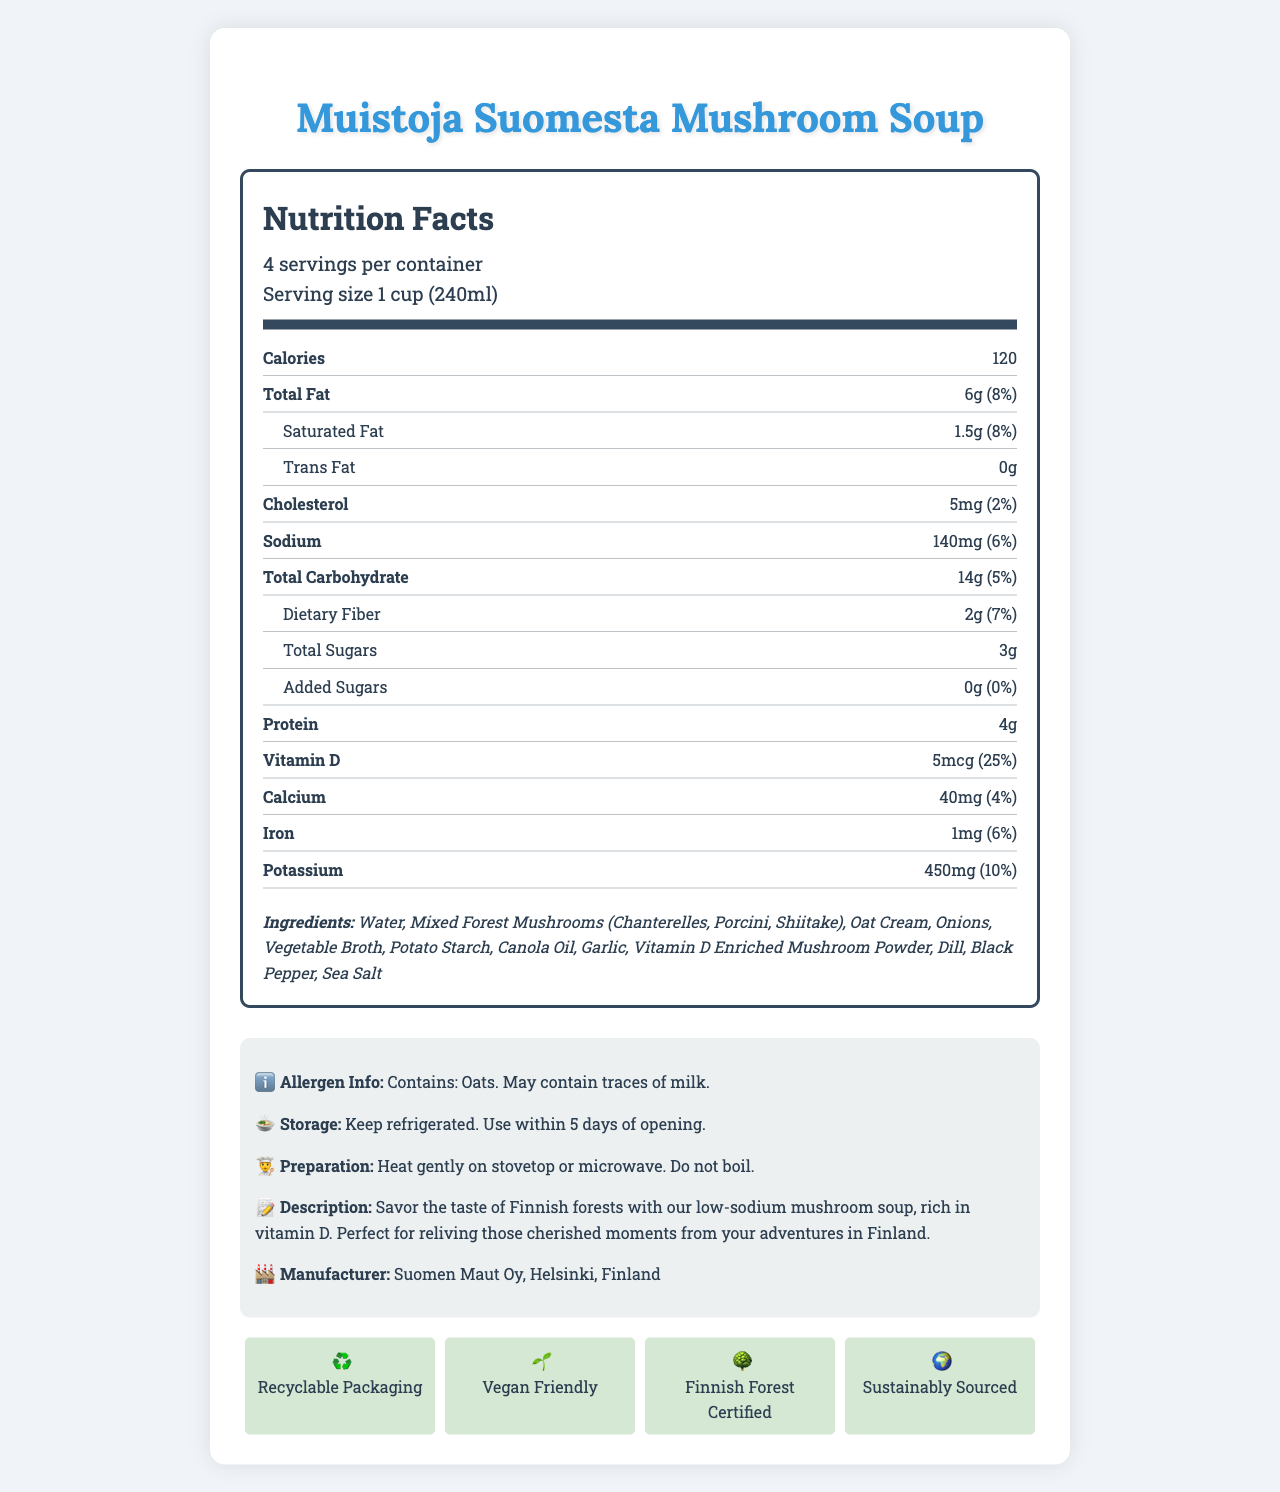what is the serving size? The serving size is stated in the serving information section as "1 cup (240ml)".
Answer: 1 cup (240ml) how many calories are in one serving? The document lists 120 calories per serving in the nutrient section.
Answer: 120 which component has the highest daily value percentage? In the nutrient section, Vitamin D has the highest daily value percentage, which is 25%.
Answer: Vitamin D (25%) what is the amount of sodium per serving? The sodium content per serving is listed as 140mg.
Answer: 140mg how much dietary fiber is in one serving? The dietary fiber content per serving is 2g and can be found in the nutrient section.
Answer: 2g which ingredient is not a mushroom? A. Chanterelles B. Oat Cream C. Porcini D. Shiitake Oat Cream is not a mushroom, while the other options are types of mushrooms.
Answer: B what is the daily value percentage for calcium? A. 2% B. 4% C. 6% D. 8% The document states that the daily value for calcium is 4%.
Answer: B is the soup vegan-friendly? The additional info section mentions that the soup is vegan-friendly.
Answer: Yes list one unique aspect of the product's packaging. The document indicates that the product uses recyclable packaging in the sustainability info section.
Answer: Recyclable Packaging what is the preparation instruction for heating the soup? The preparation instructions are to heat gently on stovetop or microwave and not to boil.
Answer: Heat gently on stovetop or microwave. Do not boil. which organization certifies the Finnish forest origin? The sustainability info section mentions that the soup is Finnish Forest Certified.
Answer: Finnish Forest Certified does the product contain milk? The allergen info states that the product may contain traces of milk.
Answer: May contain traces of milk. what serving size information is provided? The serving size is clearly listed in the serving info section.
Answer: 1 cup (240ml) what is the unique selling point highlighted in the product description? A. High Protein B. Rich in Vitamin D C. Low Carbohydrate D. High Fiber The product description highlights that the soup is rich in Vitamin D.
Answer: B is there any trans fat in the soup? The nutrient section indicates that the amount of trans fat is 0g.
Answer: No, 0g which vitamin is enriched in the mushroom powder? The ingredients list mentions Vitamin D Enriched Mushroom Powder.
Answer: Vitamin D can the calorie content of the entire container be determined? Each serving has 120 calories, and there are 4 servings per container. Total calories = 120 * 4 = 480 calories.
Answer: Yes summarize the main idea of the document. The document is a comprehensive presentation of the nutritional facts, ingredients, and other relevant information about Muistoja Suomesta Mushroom Soup, emphasizing its Finnish roots and health benefits.
Answer: The document provides detailed nutritional information about Muistoja Suomesta Mushroom Soup, highlighting its low sodium and high vitamin D content. It lists its ingredients, allergen info, preparation and storage instructions, and other product details like sustainability certifications and vegan-friendly status. what is the unique sustainability feature of the product? The additional info section mentions that the ingredients are sustainably sourced.
Answer: Sustainably sourced ingredients what is the sodium content for the entire container? Each serving has 140mg of sodium, and there are 4 servings per container. Total sodium = 140 * 4 = 560mg.
Answer: 560mg 